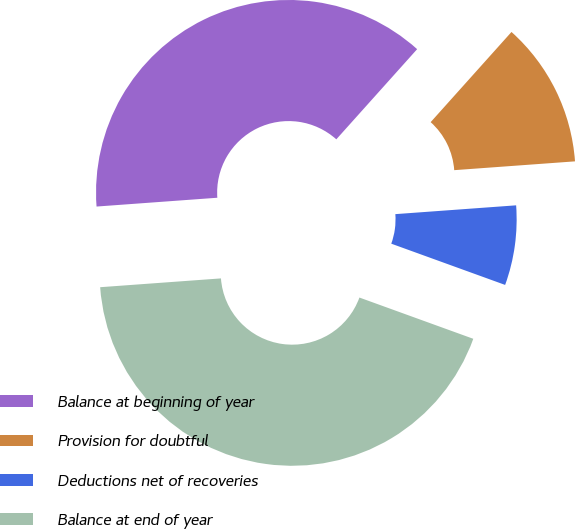Convert chart. <chart><loc_0><loc_0><loc_500><loc_500><pie_chart><fcel>Balance at beginning of year<fcel>Provision for doubtful<fcel>Deductions net of recoveries<fcel>Balance at end of year<nl><fcel>37.79%<fcel>12.21%<fcel>6.69%<fcel>43.31%<nl></chart> 